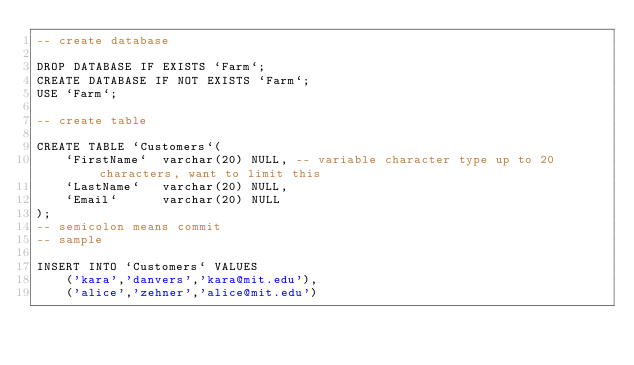<code> <loc_0><loc_0><loc_500><loc_500><_SQL_>-- create database

DROP DATABASE IF EXISTS `Farm`;
CREATE DATABASE IF NOT EXISTS `Farm`;
USE `Farm`;

-- create table

CREATE TABLE `Customers`(
    `FirstName`  varchar(20) NULL, -- variable character type up to 20 characters, want to limit this
    `LastName`   varchar(20) NULL,
    `Email`      varchar(20) NULL
);
-- semicolon means commit
-- sample

INSERT INTO `Customers` VALUES
    ('kara','danvers','kara@mit.edu'),
    ('alice','zehner','alice@mit.edu')</code> 